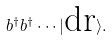Convert formula to latex. <formula><loc_0><loc_0><loc_500><loc_500>b ^ { \dag } b ^ { \dag } \cdots | \text {dr} \rangle .</formula> 